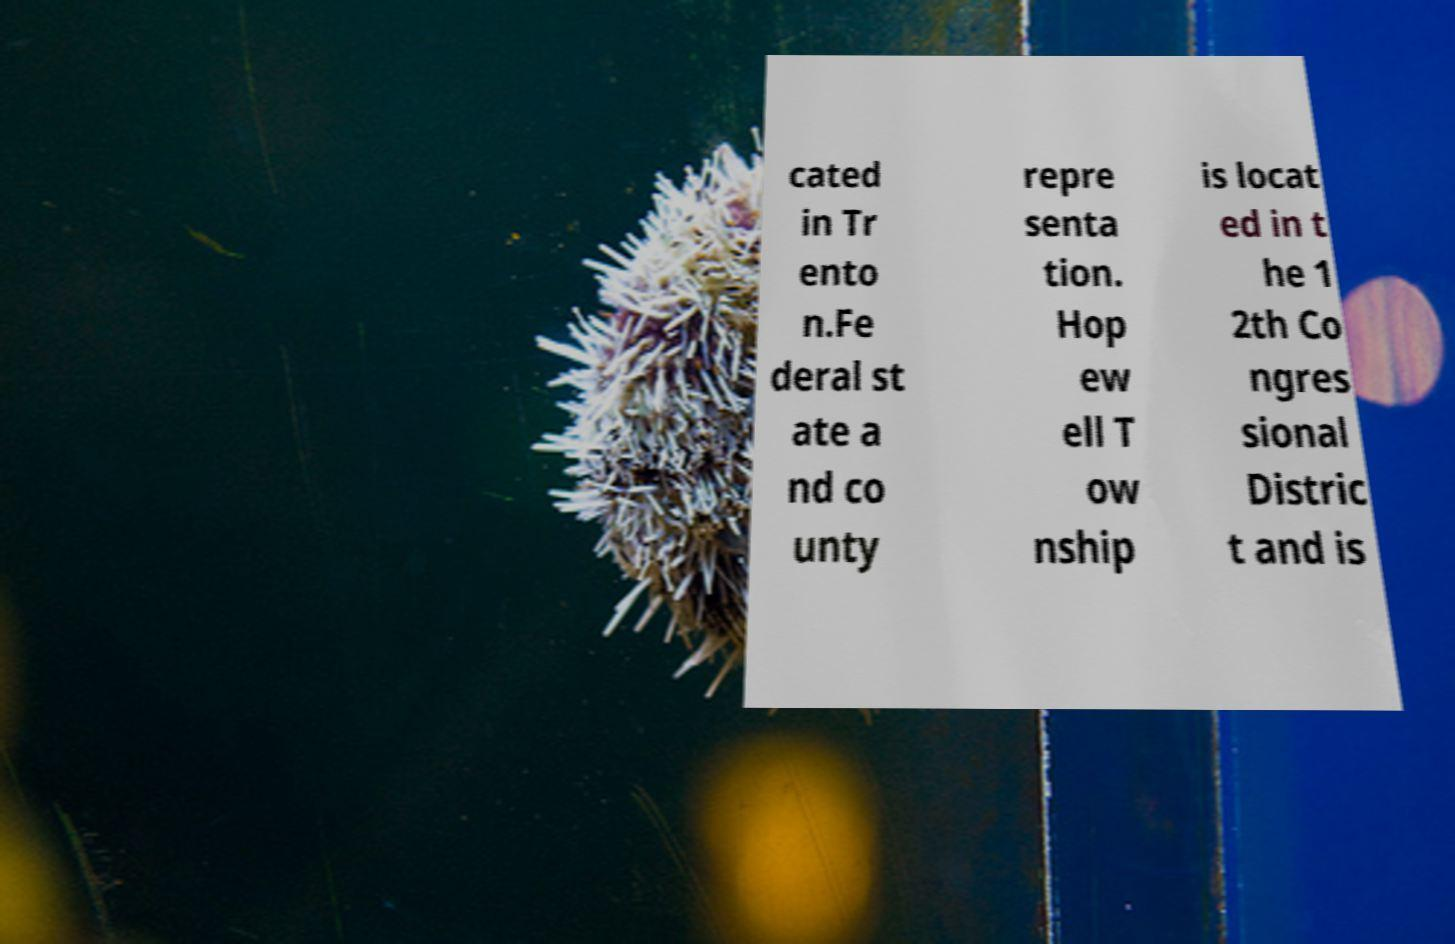Could you assist in decoding the text presented in this image and type it out clearly? cated in Tr ento n.Fe deral st ate a nd co unty repre senta tion. Hop ew ell T ow nship is locat ed in t he 1 2th Co ngres sional Distric t and is 